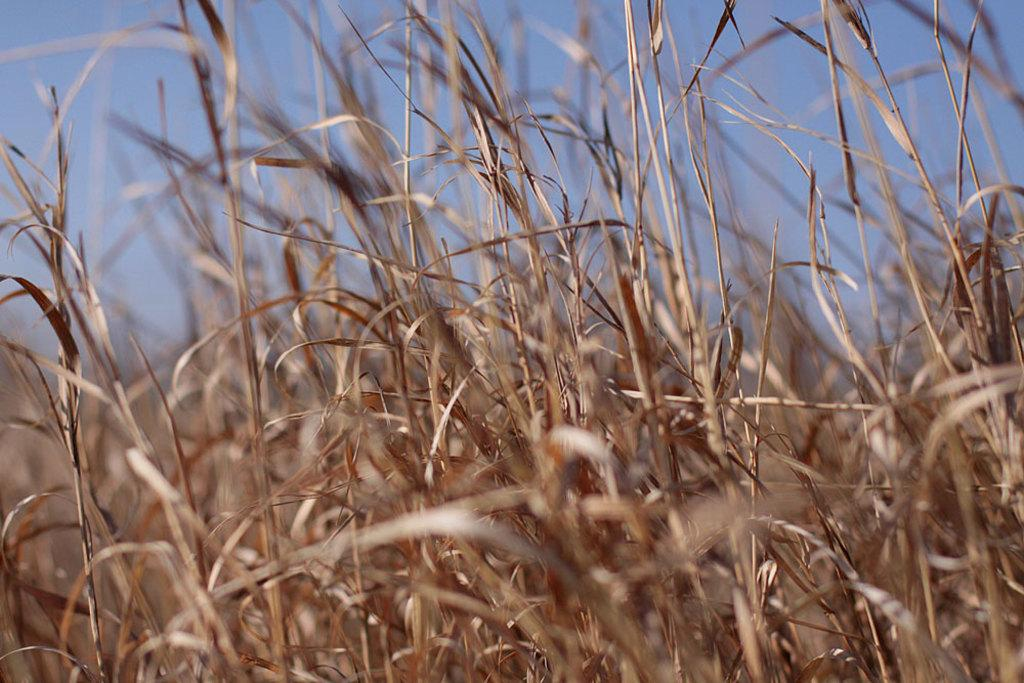What type of vegetation can be seen in the image? There is grass present in the image. What type of juice can be seen in the image? There is no juice present in the image; it only features grass. What shape is the grass forming in the image? The grass does not form a specific shape like a circle in the image; it is simply grass. 